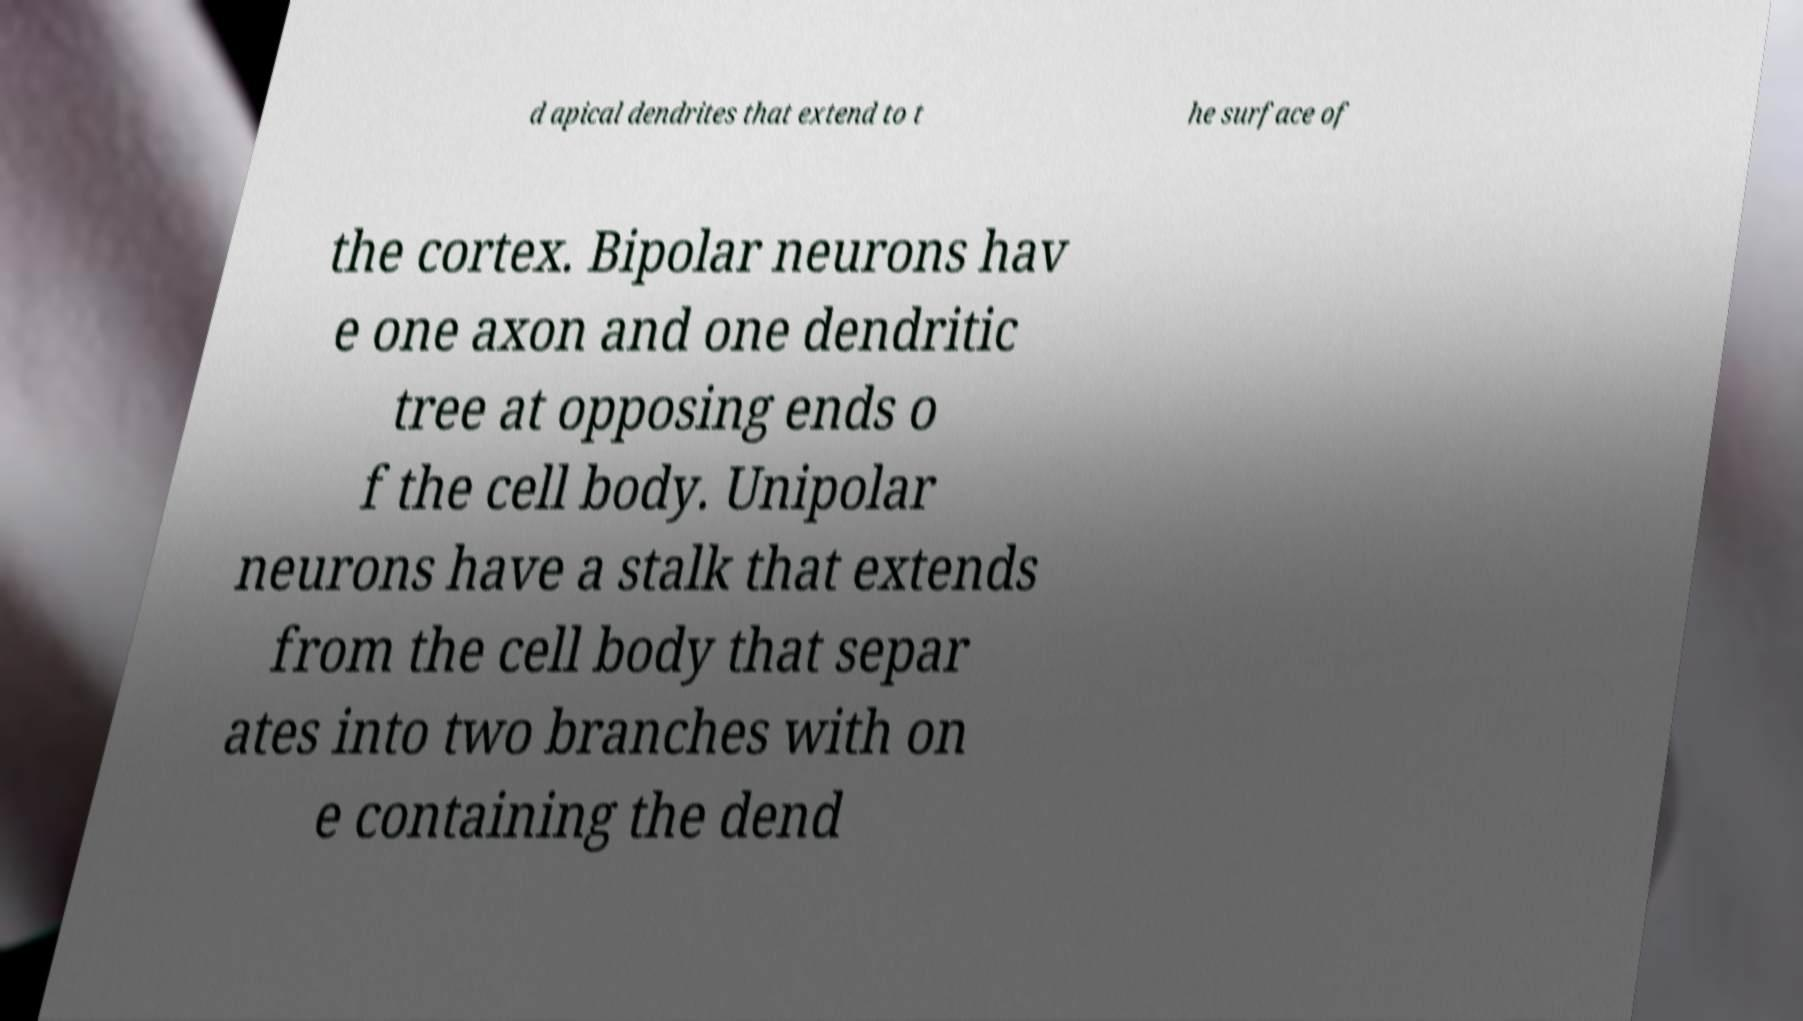Could you assist in decoding the text presented in this image and type it out clearly? d apical dendrites that extend to t he surface of the cortex. Bipolar neurons hav e one axon and one dendritic tree at opposing ends o f the cell body. Unipolar neurons have a stalk that extends from the cell body that separ ates into two branches with on e containing the dend 